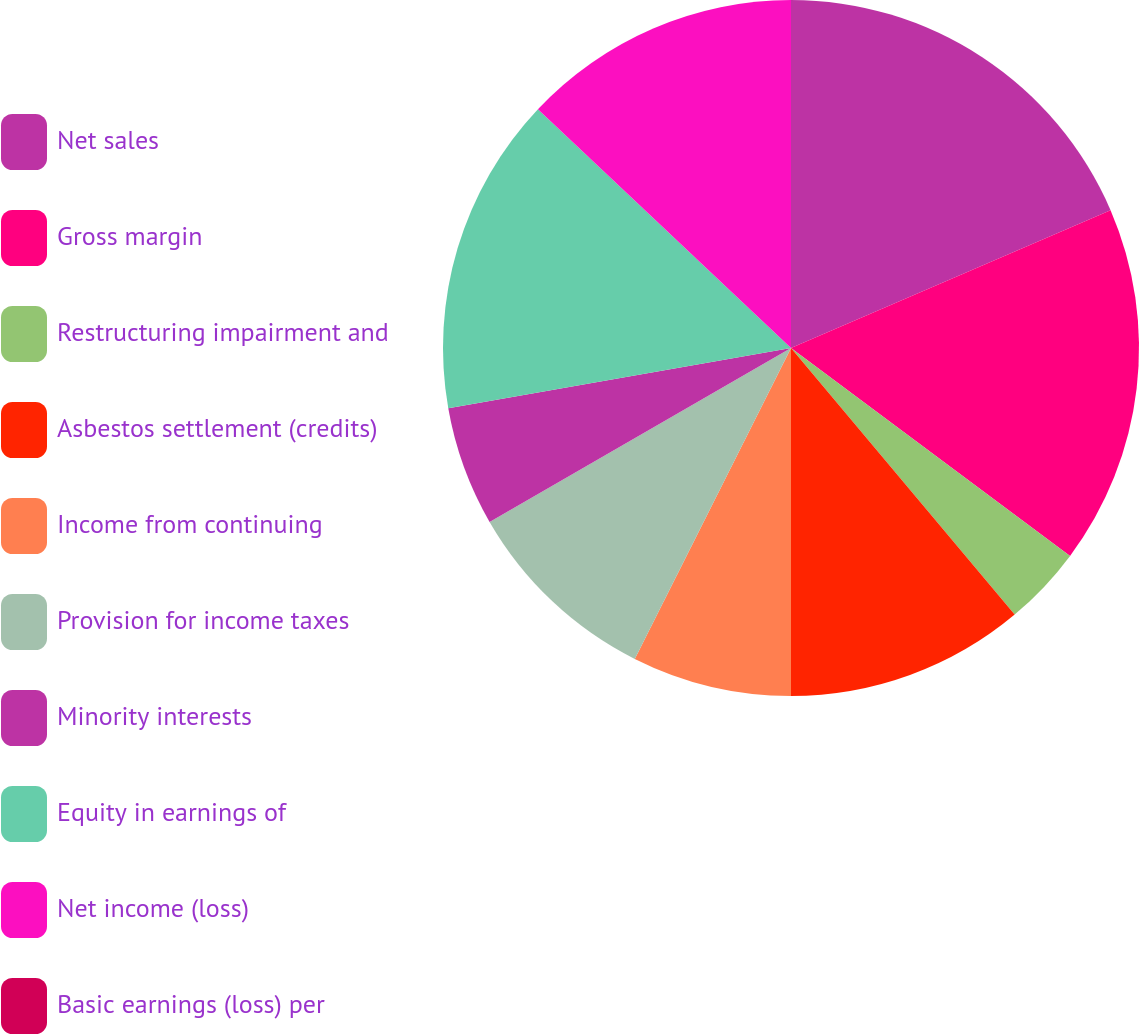Convert chart. <chart><loc_0><loc_0><loc_500><loc_500><pie_chart><fcel>Net sales<fcel>Gross margin<fcel>Restructuring impairment and<fcel>Asbestos settlement (credits)<fcel>Income from continuing<fcel>Provision for income taxes<fcel>Minority interests<fcel>Equity in earnings of<fcel>Net income (loss)<fcel>Basic earnings (loss) per<nl><fcel>18.52%<fcel>16.67%<fcel>3.7%<fcel>11.11%<fcel>7.41%<fcel>9.26%<fcel>5.56%<fcel>14.81%<fcel>12.96%<fcel>0.0%<nl></chart> 